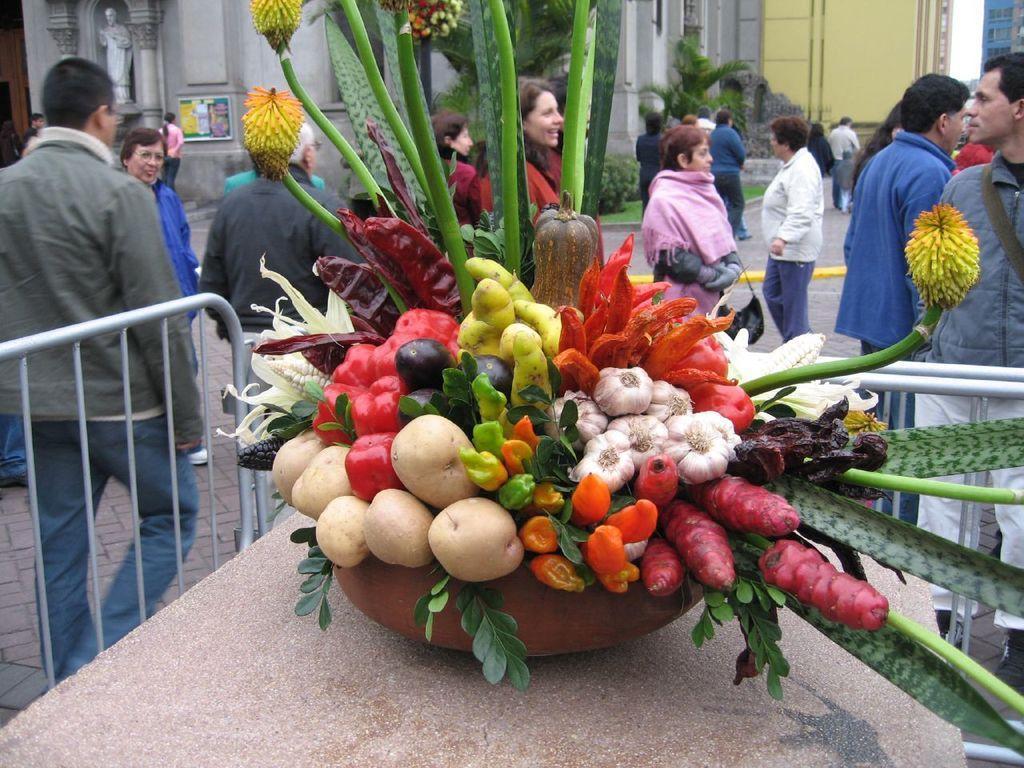Please provide a concise description of this image. In this picture we can see container with vegetables, stems and food items on the platform. There are people and we can see railings. In the background of the image we can see buildings, plants, trees, statue, board and sky. 